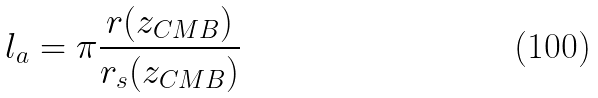<formula> <loc_0><loc_0><loc_500><loc_500>l _ { a } = \pi \frac { r ( z _ { C M B } ) } { r _ { s } ( z _ { C M B } ) }</formula> 